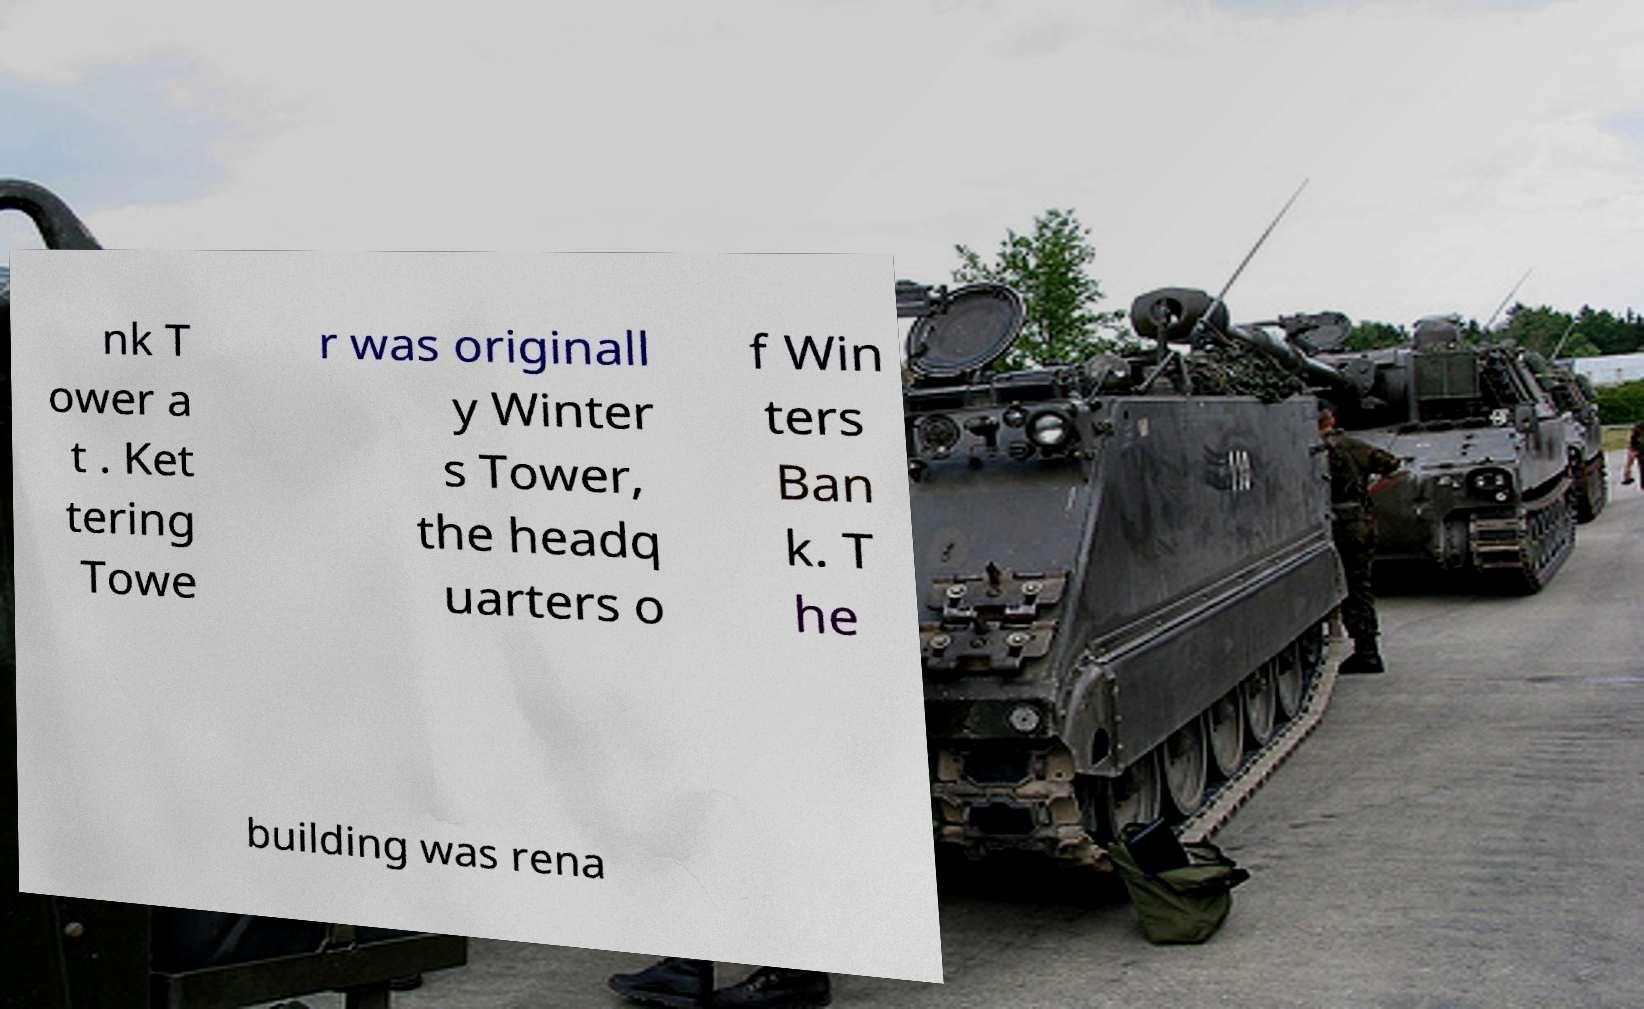Can you accurately transcribe the text from the provided image for me? nk T ower a t . Ket tering Towe r was originall y Winter s Tower, the headq uarters o f Win ters Ban k. T he building was rena 